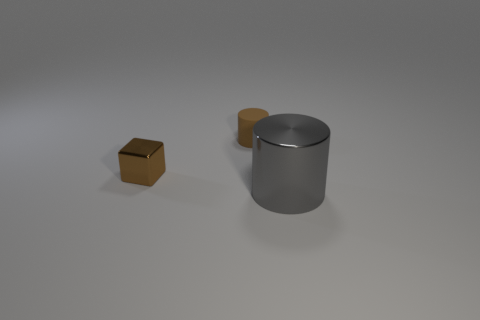There is a cylinder that is the same size as the block; what is it made of?
Provide a succinct answer. Rubber. Are there any tiny brown cubes made of the same material as the large gray cylinder?
Your answer should be compact. Yes. What shape is the metallic object that is behind the shiny thing that is in front of the brown object left of the tiny cylinder?
Offer a terse response. Cube. There is a metal block; is its size the same as the object that is to the right of the tiny brown rubber cylinder?
Provide a succinct answer. No. What is the shape of the object that is in front of the small brown rubber thing and right of the brown shiny block?
Your answer should be very brief. Cylinder. How many small things are either purple balls or rubber cylinders?
Provide a succinct answer. 1. Is the number of large gray things in front of the large gray cylinder the same as the number of brown blocks that are right of the tiny brown block?
Offer a very short reply. Yes. What number of other things are the same color as the big metallic object?
Your answer should be compact. 0. Are there the same number of gray metal objects left of the tiny metallic block and large gray metal cylinders?
Keep it short and to the point. No. Do the gray metal cylinder and the metal cube have the same size?
Your answer should be very brief. No. 